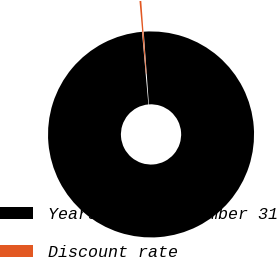Convert chart to OTSL. <chart><loc_0><loc_0><loc_500><loc_500><pie_chart><fcel>Years ended December 31<fcel>Discount rate<nl><fcel>99.72%<fcel>0.28%<nl></chart> 